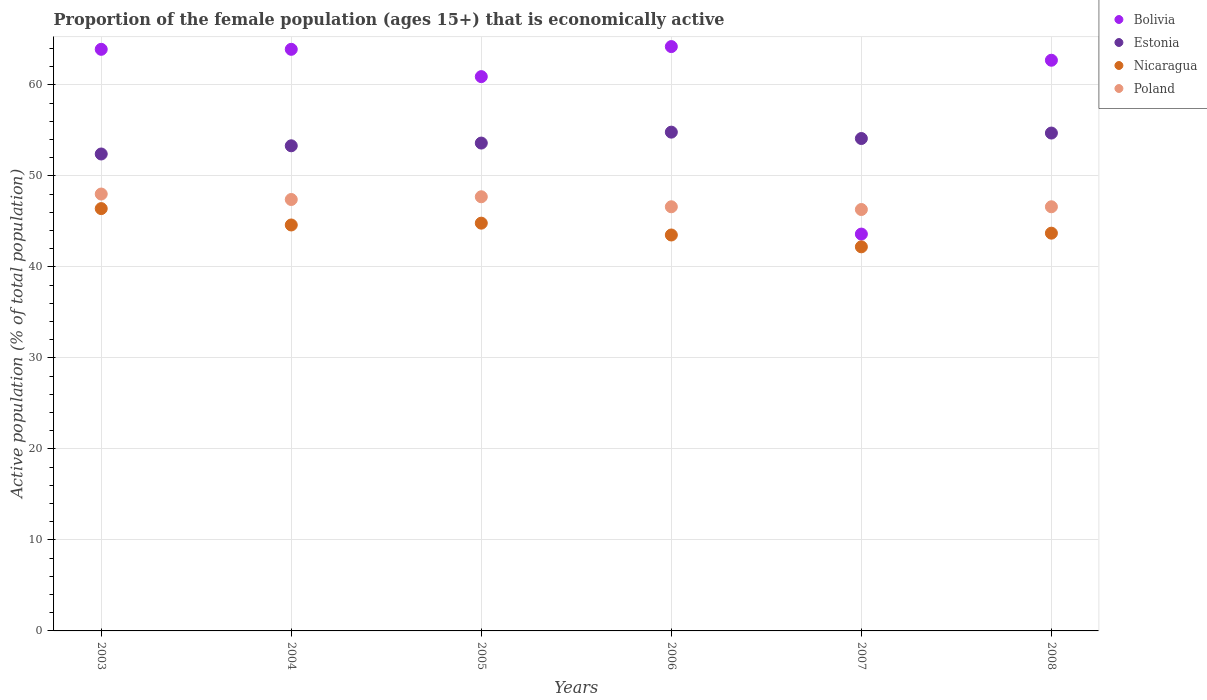What is the proportion of the female population that is economically active in Nicaragua in 2003?
Your response must be concise. 46.4. Across all years, what is the maximum proportion of the female population that is economically active in Estonia?
Your answer should be compact. 54.8. Across all years, what is the minimum proportion of the female population that is economically active in Poland?
Your answer should be compact. 46.3. In which year was the proportion of the female population that is economically active in Estonia minimum?
Offer a very short reply. 2003. What is the total proportion of the female population that is economically active in Estonia in the graph?
Your answer should be compact. 322.9. What is the difference between the proportion of the female population that is economically active in Nicaragua in 2005 and that in 2007?
Ensure brevity in your answer.  2.6. What is the difference between the proportion of the female population that is economically active in Poland in 2003 and the proportion of the female population that is economically active in Bolivia in 2008?
Ensure brevity in your answer.  -14.7. What is the average proportion of the female population that is economically active in Nicaragua per year?
Provide a short and direct response. 44.2. In the year 2006, what is the difference between the proportion of the female population that is economically active in Poland and proportion of the female population that is economically active in Bolivia?
Make the answer very short. -17.6. In how many years, is the proportion of the female population that is economically active in Bolivia greater than 10 %?
Keep it short and to the point. 6. What is the ratio of the proportion of the female population that is economically active in Estonia in 2005 to that in 2006?
Make the answer very short. 0.98. Is the proportion of the female population that is economically active in Bolivia in 2003 less than that in 2007?
Your answer should be compact. No. Is the difference between the proportion of the female population that is economically active in Poland in 2004 and 2007 greater than the difference between the proportion of the female population that is economically active in Bolivia in 2004 and 2007?
Make the answer very short. No. What is the difference between the highest and the second highest proportion of the female population that is economically active in Estonia?
Make the answer very short. 0.1. What is the difference between the highest and the lowest proportion of the female population that is economically active in Estonia?
Keep it short and to the point. 2.4. Is the sum of the proportion of the female population that is economically active in Bolivia in 2004 and 2006 greater than the maximum proportion of the female population that is economically active in Estonia across all years?
Offer a very short reply. Yes. Is it the case that in every year, the sum of the proportion of the female population that is economically active in Nicaragua and proportion of the female population that is economically active in Poland  is greater than the sum of proportion of the female population that is economically active in Bolivia and proportion of the female population that is economically active in Estonia?
Give a very brief answer. No. Is it the case that in every year, the sum of the proportion of the female population that is economically active in Nicaragua and proportion of the female population that is economically active in Bolivia  is greater than the proportion of the female population that is economically active in Estonia?
Your answer should be compact. Yes. Does the proportion of the female population that is economically active in Nicaragua monotonically increase over the years?
Keep it short and to the point. No. Is the proportion of the female population that is economically active in Estonia strictly greater than the proportion of the female population that is economically active in Poland over the years?
Offer a terse response. Yes. Is the proportion of the female population that is economically active in Estonia strictly less than the proportion of the female population that is economically active in Nicaragua over the years?
Your response must be concise. No. What is the difference between two consecutive major ticks on the Y-axis?
Offer a terse response. 10. Are the values on the major ticks of Y-axis written in scientific E-notation?
Make the answer very short. No. Does the graph contain any zero values?
Keep it short and to the point. No. How are the legend labels stacked?
Make the answer very short. Vertical. What is the title of the graph?
Provide a short and direct response. Proportion of the female population (ages 15+) that is economically active. Does "Lebanon" appear as one of the legend labels in the graph?
Ensure brevity in your answer.  No. What is the label or title of the Y-axis?
Your answer should be very brief. Active population (% of total population). What is the Active population (% of total population) of Bolivia in 2003?
Your response must be concise. 63.9. What is the Active population (% of total population) in Estonia in 2003?
Your answer should be compact. 52.4. What is the Active population (% of total population) in Nicaragua in 2003?
Give a very brief answer. 46.4. What is the Active population (% of total population) of Bolivia in 2004?
Keep it short and to the point. 63.9. What is the Active population (% of total population) of Estonia in 2004?
Provide a succinct answer. 53.3. What is the Active population (% of total population) of Nicaragua in 2004?
Your answer should be compact. 44.6. What is the Active population (% of total population) of Poland in 2004?
Offer a terse response. 47.4. What is the Active population (% of total population) in Bolivia in 2005?
Your answer should be very brief. 60.9. What is the Active population (% of total population) in Estonia in 2005?
Ensure brevity in your answer.  53.6. What is the Active population (% of total population) of Nicaragua in 2005?
Make the answer very short. 44.8. What is the Active population (% of total population) in Poland in 2005?
Your answer should be compact. 47.7. What is the Active population (% of total population) in Bolivia in 2006?
Keep it short and to the point. 64.2. What is the Active population (% of total population) of Estonia in 2006?
Provide a short and direct response. 54.8. What is the Active population (% of total population) in Nicaragua in 2006?
Your answer should be compact. 43.5. What is the Active population (% of total population) in Poland in 2006?
Give a very brief answer. 46.6. What is the Active population (% of total population) in Bolivia in 2007?
Your answer should be very brief. 43.6. What is the Active population (% of total population) of Estonia in 2007?
Ensure brevity in your answer.  54.1. What is the Active population (% of total population) of Nicaragua in 2007?
Offer a terse response. 42.2. What is the Active population (% of total population) in Poland in 2007?
Provide a short and direct response. 46.3. What is the Active population (% of total population) of Bolivia in 2008?
Provide a succinct answer. 62.7. What is the Active population (% of total population) of Estonia in 2008?
Keep it short and to the point. 54.7. What is the Active population (% of total population) in Nicaragua in 2008?
Ensure brevity in your answer.  43.7. What is the Active population (% of total population) in Poland in 2008?
Your answer should be very brief. 46.6. Across all years, what is the maximum Active population (% of total population) in Bolivia?
Provide a succinct answer. 64.2. Across all years, what is the maximum Active population (% of total population) in Estonia?
Your answer should be very brief. 54.8. Across all years, what is the maximum Active population (% of total population) in Nicaragua?
Your answer should be compact. 46.4. Across all years, what is the minimum Active population (% of total population) in Bolivia?
Make the answer very short. 43.6. Across all years, what is the minimum Active population (% of total population) of Estonia?
Provide a short and direct response. 52.4. Across all years, what is the minimum Active population (% of total population) of Nicaragua?
Offer a very short reply. 42.2. Across all years, what is the minimum Active population (% of total population) of Poland?
Ensure brevity in your answer.  46.3. What is the total Active population (% of total population) of Bolivia in the graph?
Provide a short and direct response. 359.2. What is the total Active population (% of total population) of Estonia in the graph?
Provide a succinct answer. 322.9. What is the total Active population (% of total population) in Nicaragua in the graph?
Offer a terse response. 265.2. What is the total Active population (% of total population) of Poland in the graph?
Offer a terse response. 282.6. What is the difference between the Active population (% of total population) in Estonia in 2003 and that in 2004?
Provide a short and direct response. -0.9. What is the difference between the Active population (% of total population) in Nicaragua in 2003 and that in 2004?
Provide a short and direct response. 1.8. What is the difference between the Active population (% of total population) in Nicaragua in 2003 and that in 2005?
Offer a very short reply. 1.6. What is the difference between the Active population (% of total population) of Poland in 2003 and that in 2005?
Ensure brevity in your answer.  0.3. What is the difference between the Active population (% of total population) of Estonia in 2003 and that in 2006?
Offer a terse response. -2.4. What is the difference between the Active population (% of total population) in Poland in 2003 and that in 2006?
Your response must be concise. 1.4. What is the difference between the Active population (% of total population) of Bolivia in 2003 and that in 2007?
Your answer should be very brief. 20.3. What is the difference between the Active population (% of total population) in Estonia in 2003 and that in 2007?
Keep it short and to the point. -1.7. What is the difference between the Active population (% of total population) in Bolivia in 2003 and that in 2008?
Give a very brief answer. 1.2. What is the difference between the Active population (% of total population) of Estonia in 2003 and that in 2008?
Your response must be concise. -2.3. What is the difference between the Active population (% of total population) in Poland in 2003 and that in 2008?
Your response must be concise. 1.4. What is the difference between the Active population (% of total population) in Bolivia in 2004 and that in 2006?
Your answer should be compact. -0.3. What is the difference between the Active population (% of total population) of Nicaragua in 2004 and that in 2006?
Your response must be concise. 1.1. What is the difference between the Active population (% of total population) in Poland in 2004 and that in 2006?
Offer a terse response. 0.8. What is the difference between the Active population (% of total population) in Bolivia in 2004 and that in 2007?
Keep it short and to the point. 20.3. What is the difference between the Active population (% of total population) in Poland in 2004 and that in 2007?
Your answer should be compact. 1.1. What is the difference between the Active population (% of total population) in Poland in 2004 and that in 2008?
Your response must be concise. 0.8. What is the difference between the Active population (% of total population) in Bolivia in 2005 and that in 2006?
Your answer should be compact. -3.3. What is the difference between the Active population (% of total population) in Nicaragua in 2005 and that in 2006?
Keep it short and to the point. 1.3. What is the difference between the Active population (% of total population) in Poland in 2005 and that in 2007?
Offer a terse response. 1.4. What is the difference between the Active population (% of total population) of Estonia in 2005 and that in 2008?
Offer a very short reply. -1.1. What is the difference between the Active population (% of total population) in Nicaragua in 2005 and that in 2008?
Offer a very short reply. 1.1. What is the difference between the Active population (% of total population) of Poland in 2005 and that in 2008?
Provide a succinct answer. 1.1. What is the difference between the Active population (% of total population) in Bolivia in 2006 and that in 2007?
Your response must be concise. 20.6. What is the difference between the Active population (% of total population) in Estonia in 2006 and that in 2007?
Keep it short and to the point. 0.7. What is the difference between the Active population (% of total population) in Bolivia in 2006 and that in 2008?
Provide a succinct answer. 1.5. What is the difference between the Active population (% of total population) in Nicaragua in 2006 and that in 2008?
Your response must be concise. -0.2. What is the difference between the Active population (% of total population) of Poland in 2006 and that in 2008?
Keep it short and to the point. 0. What is the difference between the Active population (% of total population) of Bolivia in 2007 and that in 2008?
Make the answer very short. -19.1. What is the difference between the Active population (% of total population) of Nicaragua in 2007 and that in 2008?
Your answer should be very brief. -1.5. What is the difference between the Active population (% of total population) in Bolivia in 2003 and the Active population (% of total population) in Estonia in 2004?
Offer a terse response. 10.6. What is the difference between the Active population (% of total population) of Bolivia in 2003 and the Active population (% of total population) of Nicaragua in 2004?
Keep it short and to the point. 19.3. What is the difference between the Active population (% of total population) in Bolivia in 2003 and the Active population (% of total population) in Poland in 2004?
Make the answer very short. 16.5. What is the difference between the Active population (% of total population) in Estonia in 2003 and the Active population (% of total population) in Nicaragua in 2004?
Offer a very short reply. 7.8. What is the difference between the Active population (% of total population) of Bolivia in 2003 and the Active population (% of total population) of Estonia in 2005?
Your answer should be very brief. 10.3. What is the difference between the Active population (% of total population) of Bolivia in 2003 and the Active population (% of total population) of Nicaragua in 2005?
Provide a short and direct response. 19.1. What is the difference between the Active population (% of total population) in Estonia in 2003 and the Active population (% of total population) in Nicaragua in 2005?
Provide a succinct answer. 7.6. What is the difference between the Active population (% of total population) of Bolivia in 2003 and the Active population (% of total population) of Estonia in 2006?
Ensure brevity in your answer.  9.1. What is the difference between the Active population (% of total population) in Bolivia in 2003 and the Active population (% of total population) in Nicaragua in 2006?
Your answer should be very brief. 20.4. What is the difference between the Active population (% of total population) of Nicaragua in 2003 and the Active population (% of total population) of Poland in 2006?
Make the answer very short. -0.2. What is the difference between the Active population (% of total population) in Bolivia in 2003 and the Active population (% of total population) in Estonia in 2007?
Provide a succinct answer. 9.8. What is the difference between the Active population (% of total population) in Bolivia in 2003 and the Active population (% of total population) in Nicaragua in 2007?
Ensure brevity in your answer.  21.7. What is the difference between the Active population (% of total population) of Bolivia in 2003 and the Active population (% of total population) of Poland in 2007?
Your answer should be compact. 17.6. What is the difference between the Active population (% of total population) in Estonia in 2003 and the Active population (% of total population) in Poland in 2007?
Provide a succinct answer. 6.1. What is the difference between the Active population (% of total population) in Bolivia in 2003 and the Active population (% of total population) in Estonia in 2008?
Give a very brief answer. 9.2. What is the difference between the Active population (% of total population) of Bolivia in 2003 and the Active population (% of total population) of Nicaragua in 2008?
Your answer should be compact. 20.2. What is the difference between the Active population (% of total population) in Bolivia in 2003 and the Active population (% of total population) in Poland in 2008?
Provide a succinct answer. 17.3. What is the difference between the Active population (% of total population) in Estonia in 2003 and the Active population (% of total population) in Poland in 2008?
Offer a terse response. 5.8. What is the difference between the Active population (% of total population) of Bolivia in 2004 and the Active population (% of total population) of Nicaragua in 2005?
Your response must be concise. 19.1. What is the difference between the Active population (% of total population) in Bolivia in 2004 and the Active population (% of total population) in Poland in 2005?
Offer a very short reply. 16.2. What is the difference between the Active population (% of total population) in Estonia in 2004 and the Active population (% of total population) in Nicaragua in 2005?
Your answer should be very brief. 8.5. What is the difference between the Active population (% of total population) in Nicaragua in 2004 and the Active population (% of total population) in Poland in 2005?
Give a very brief answer. -3.1. What is the difference between the Active population (% of total population) of Bolivia in 2004 and the Active population (% of total population) of Estonia in 2006?
Ensure brevity in your answer.  9.1. What is the difference between the Active population (% of total population) in Bolivia in 2004 and the Active population (% of total population) in Nicaragua in 2006?
Offer a very short reply. 20.4. What is the difference between the Active population (% of total population) of Estonia in 2004 and the Active population (% of total population) of Nicaragua in 2006?
Your response must be concise. 9.8. What is the difference between the Active population (% of total population) in Estonia in 2004 and the Active population (% of total population) in Poland in 2006?
Offer a very short reply. 6.7. What is the difference between the Active population (% of total population) in Nicaragua in 2004 and the Active population (% of total population) in Poland in 2006?
Give a very brief answer. -2. What is the difference between the Active population (% of total population) of Bolivia in 2004 and the Active population (% of total population) of Estonia in 2007?
Offer a very short reply. 9.8. What is the difference between the Active population (% of total population) in Bolivia in 2004 and the Active population (% of total population) in Nicaragua in 2007?
Keep it short and to the point. 21.7. What is the difference between the Active population (% of total population) of Estonia in 2004 and the Active population (% of total population) of Nicaragua in 2007?
Your answer should be compact. 11.1. What is the difference between the Active population (% of total population) in Estonia in 2004 and the Active population (% of total population) in Poland in 2007?
Ensure brevity in your answer.  7. What is the difference between the Active population (% of total population) in Nicaragua in 2004 and the Active population (% of total population) in Poland in 2007?
Your response must be concise. -1.7. What is the difference between the Active population (% of total population) of Bolivia in 2004 and the Active population (% of total population) of Estonia in 2008?
Keep it short and to the point. 9.2. What is the difference between the Active population (% of total population) in Bolivia in 2004 and the Active population (% of total population) in Nicaragua in 2008?
Provide a short and direct response. 20.2. What is the difference between the Active population (% of total population) in Bolivia in 2005 and the Active population (% of total population) in Nicaragua in 2006?
Make the answer very short. 17.4. What is the difference between the Active population (% of total population) in Bolivia in 2005 and the Active population (% of total population) in Poland in 2006?
Offer a terse response. 14.3. What is the difference between the Active population (% of total population) in Bolivia in 2005 and the Active population (% of total population) in Estonia in 2007?
Offer a very short reply. 6.8. What is the difference between the Active population (% of total population) of Estonia in 2005 and the Active population (% of total population) of Nicaragua in 2007?
Make the answer very short. 11.4. What is the difference between the Active population (% of total population) in Nicaragua in 2005 and the Active population (% of total population) in Poland in 2007?
Provide a short and direct response. -1.5. What is the difference between the Active population (% of total population) in Bolivia in 2005 and the Active population (% of total population) in Nicaragua in 2008?
Make the answer very short. 17.2. What is the difference between the Active population (% of total population) of Bolivia in 2005 and the Active population (% of total population) of Poland in 2008?
Give a very brief answer. 14.3. What is the difference between the Active population (% of total population) of Nicaragua in 2005 and the Active population (% of total population) of Poland in 2008?
Keep it short and to the point. -1.8. What is the difference between the Active population (% of total population) of Bolivia in 2006 and the Active population (% of total population) of Nicaragua in 2007?
Provide a succinct answer. 22. What is the difference between the Active population (% of total population) of Bolivia in 2006 and the Active population (% of total population) of Poland in 2007?
Give a very brief answer. 17.9. What is the difference between the Active population (% of total population) of Estonia in 2006 and the Active population (% of total population) of Poland in 2007?
Ensure brevity in your answer.  8.5. What is the difference between the Active population (% of total population) in Nicaragua in 2006 and the Active population (% of total population) in Poland in 2007?
Give a very brief answer. -2.8. What is the difference between the Active population (% of total population) of Bolivia in 2006 and the Active population (% of total population) of Poland in 2008?
Offer a very short reply. 17.6. What is the difference between the Active population (% of total population) of Estonia in 2006 and the Active population (% of total population) of Nicaragua in 2008?
Offer a terse response. 11.1. What is the difference between the Active population (% of total population) in Estonia in 2007 and the Active population (% of total population) in Poland in 2008?
Your response must be concise. 7.5. What is the difference between the Active population (% of total population) of Nicaragua in 2007 and the Active population (% of total population) of Poland in 2008?
Your answer should be very brief. -4.4. What is the average Active population (% of total population) of Bolivia per year?
Keep it short and to the point. 59.87. What is the average Active population (% of total population) of Estonia per year?
Provide a succinct answer. 53.82. What is the average Active population (% of total population) of Nicaragua per year?
Offer a very short reply. 44.2. What is the average Active population (% of total population) in Poland per year?
Ensure brevity in your answer.  47.1. In the year 2003, what is the difference between the Active population (% of total population) of Bolivia and Active population (% of total population) of Estonia?
Make the answer very short. 11.5. In the year 2003, what is the difference between the Active population (% of total population) of Bolivia and Active population (% of total population) of Nicaragua?
Your answer should be very brief. 17.5. In the year 2003, what is the difference between the Active population (% of total population) in Bolivia and Active population (% of total population) in Poland?
Provide a succinct answer. 15.9. In the year 2003, what is the difference between the Active population (% of total population) of Estonia and Active population (% of total population) of Nicaragua?
Provide a succinct answer. 6. In the year 2003, what is the difference between the Active population (% of total population) in Estonia and Active population (% of total population) in Poland?
Give a very brief answer. 4.4. In the year 2004, what is the difference between the Active population (% of total population) of Bolivia and Active population (% of total population) of Nicaragua?
Provide a succinct answer. 19.3. In the year 2004, what is the difference between the Active population (% of total population) in Bolivia and Active population (% of total population) in Poland?
Provide a succinct answer. 16.5. In the year 2004, what is the difference between the Active population (% of total population) in Estonia and Active population (% of total population) in Nicaragua?
Your response must be concise. 8.7. In the year 2004, what is the difference between the Active population (% of total population) in Estonia and Active population (% of total population) in Poland?
Provide a short and direct response. 5.9. In the year 2005, what is the difference between the Active population (% of total population) in Bolivia and Active population (% of total population) in Nicaragua?
Offer a very short reply. 16.1. In the year 2005, what is the difference between the Active population (% of total population) in Estonia and Active population (% of total population) in Nicaragua?
Your response must be concise. 8.8. In the year 2005, what is the difference between the Active population (% of total population) in Estonia and Active population (% of total population) in Poland?
Offer a very short reply. 5.9. In the year 2005, what is the difference between the Active population (% of total population) in Nicaragua and Active population (% of total population) in Poland?
Provide a short and direct response. -2.9. In the year 2006, what is the difference between the Active population (% of total population) of Bolivia and Active population (% of total population) of Estonia?
Your answer should be very brief. 9.4. In the year 2006, what is the difference between the Active population (% of total population) in Bolivia and Active population (% of total population) in Nicaragua?
Your answer should be very brief. 20.7. In the year 2006, what is the difference between the Active population (% of total population) in Estonia and Active population (% of total population) in Nicaragua?
Make the answer very short. 11.3. In the year 2006, what is the difference between the Active population (% of total population) of Estonia and Active population (% of total population) of Poland?
Ensure brevity in your answer.  8.2. In the year 2006, what is the difference between the Active population (% of total population) of Nicaragua and Active population (% of total population) of Poland?
Offer a terse response. -3.1. In the year 2007, what is the difference between the Active population (% of total population) in Bolivia and Active population (% of total population) in Nicaragua?
Give a very brief answer. 1.4. In the year 2007, what is the difference between the Active population (% of total population) in Bolivia and Active population (% of total population) in Poland?
Make the answer very short. -2.7. In the year 2007, what is the difference between the Active population (% of total population) of Estonia and Active population (% of total population) of Nicaragua?
Provide a short and direct response. 11.9. In the year 2008, what is the difference between the Active population (% of total population) of Bolivia and Active population (% of total population) of Poland?
Your answer should be very brief. 16.1. In the year 2008, what is the difference between the Active population (% of total population) in Estonia and Active population (% of total population) in Poland?
Your answer should be compact. 8.1. In the year 2008, what is the difference between the Active population (% of total population) in Nicaragua and Active population (% of total population) in Poland?
Ensure brevity in your answer.  -2.9. What is the ratio of the Active population (% of total population) of Estonia in 2003 to that in 2004?
Ensure brevity in your answer.  0.98. What is the ratio of the Active population (% of total population) in Nicaragua in 2003 to that in 2004?
Keep it short and to the point. 1.04. What is the ratio of the Active population (% of total population) in Poland in 2003 to that in 2004?
Your answer should be compact. 1.01. What is the ratio of the Active population (% of total population) in Bolivia in 2003 to that in 2005?
Your answer should be very brief. 1.05. What is the ratio of the Active population (% of total population) of Estonia in 2003 to that in 2005?
Your answer should be compact. 0.98. What is the ratio of the Active population (% of total population) of Nicaragua in 2003 to that in 2005?
Offer a terse response. 1.04. What is the ratio of the Active population (% of total population) of Estonia in 2003 to that in 2006?
Ensure brevity in your answer.  0.96. What is the ratio of the Active population (% of total population) of Nicaragua in 2003 to that in 2006?
Give a very brief answer. 1.07. What is the ratio of the Active population (% of total population) in Bolivia in 2003 to that in 2007?
Offer a terse response. 1.47. What is the ratio of the Active population (% of total population) of Estonia in 2003 to that in 2007?
Your response must be concise. 0.97. What is the ratio of the Active population (% of total population) of Nicaragua in 2003 to that in 2007?
Your answer should be very brief. 1.1. What is the ratio of the Active population (% of total population) of Poland in 2003 to that in 2007?
Ensure brevity in your answer.  1.04. What is the ratio of the Active population (% of total population) of Bolivia in 2003 to that in 2008?
Your answer should be compact. 1.02. What is the ratio of the Active population (% of total population) in Estonia in 2003 to that in 2008?
Provide a short and direct response. 0.96. What is the ratio of the Active population (% of total population) in Nicaragua in 2003 to that in 2008?
Your answer should be very brief. 1.06. What is the ratio of the Active population (% of total population) of Bolivia in 2004 to that in 2005?
Give a very brief answer. 1.05. What is the ratio of the Active population (% of total population) in Bolivia in 2004 to that in 2006?
Your answer should be very brief. 1. What is the ratio of the Active population (% of total population) of Estonia in 2004 to that in 2006?
Your response must be concise. 0.97. What is the ratio of the Active population (% of total population) of Nicaragua in 2004 to that in 2006?
Keep it short and to the point. 1.03. What is the ratio of the Active population (% of total population) of Poland in 2004 to that in 2006?
Your answer should be compact. 1.02. What is the ratio of the Active population (% of total population) in Bolivia in 2004 to that in 2007?
Offer a very short reply. 1.47. What is the ratio of the Active population (% of total population) in Estonia in 2004 to that in 2007?
Make the answer very short. 0.99. What is the ratio of the Active population (% of total population) of Nicaragua in 2004 to that in 2007?
Ensure brevity in your answer.  1.06. What is the ratio of the Active population (% of total population) of Poland in 2004 to that in 2007?
Keep it short and to the point. 1.02. What is the ratio of the Active population (% of total population) in Bolivia in 2004 to that in 2008?
Make the answer very short. 1.02. What is the ratio of the Active population (% of total population) in Estonia in 2004 to that in 2008?
Offer a very short reply. 0.97. What is the ratio of the Active population (% of total population) in Nicaragua in 2004 to that in 2008?
Offer a terse response. 1.02. What is the ratio of the Active population (% of total population) in Poland in 2004 to that in 2008?
Your answer should be compact. 1.02. What is the ratio of the Active population (% of total population) of Bolivia in 2005 to that in 2006?
Your answer should be very brief. 0.95. What is the ratio of the Active population (% of total population) in Estonia in 2005 to that in 2006?
Offer a very short reply. 0.98. What is the ratio of the Active population (% of total population) of Nicaragua in 2005 to that in 2006?
Give a very brief answer. 1.03. What is the ratio of the Active population (% of total population) in Poland in 2005 to that in 2006?
Your response must be concise. 1.02. What is the ratio of the Active population (% of total population) in Bolivia in 2005 to that in 2007?
Your answer should be very brief. 1.4. What is the ratio of the Active population (% of total population) in Nicaragua in 2005 to that in 2007?
Your response must be concise. 1.06. What is the ratio of the Active population (% of total population) of Poland in 2005 to that in 2007?
Offer a terse response. 1.03. What is the ratio of the Active population (% of total population) in Bolivia in 2005 to that in 2008?
Your answer should be compact. 0.97. What is the ratio of the Active population (% of total population) in Estonia in 2005 to that in 2008?
Make the answer very short. 0.98. What is the ratio of the Active population (% of total population) of Nicaragua in 2005 to that in 2008?
Give a very brief answer. 1.03. What is the ratio of the Active population (% of total population) in Poland in 2005 to that in 2008?
Ensure brevity in your answer.  1.02. What is the ratio of the Active population (% of total population) of Bolivia in 2006 to that in 2007?
Offer a very short reply. 1.47. What is the ratio of the Active population (% of total population) of Estonia in 2006 to that in 2007?
Ensure brevity in your answer.  1.01. What is the ratio of the Active population (% of total population) of Nicaragua in 2006 to that in 2007?
Provide a short and direct response. 1.03. What is the ratio of the Active population (% of total population) in Bolivia in 2006 to that in 2008?
Provide a short and direct response. 1.02. What is the ratio of the Active population (% of total population) in Nicaragua in 2006 to that in 2008?
Offer a very short reply. 1. What is the ratio of the Active population (% of total population) in Bolivia in 2007 to that in 2008?
Your response must be concise. 0.7. What is the ratio of the Active population (% of total population) in Nicaragua in 2007 to that in 2008?
Provide a short and direct response. 0.97. What is the ratio of the Active population (% of total population) of Poland in 2007 to that in 2008?
Your answer should be very brief. 0.99. What is the difference between the highest and the second highest Active population (% of total population) in Poland?
Offer a very short reply. 0.3. What is the difference between the highest and the lowest Active population (% of total population) in Bolivia?
Offer a terse response. 20.6. What is the difference between the highest and the lowest Active population (% of total population) in Nicaragua?
Your answer should be compact. 4.2. What is the difference between the highest and the lowest Active population (% of total population) of Poland?
Provide a succinct answer. 1.7. 